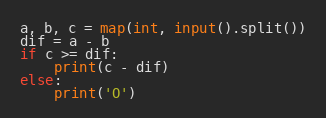<code> <loc_0><loc_0><loc_500><loc_500><_Python_>a, b, c = map(int, input().split())
dif = a - b
if c >= dif:
    print(c - dif)
else:
    print('O')</code> 